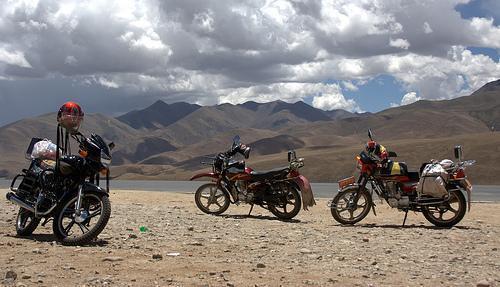How many motorcycles are in the picture?
Give a very brief answer. 3. How many tires are in the picture?
Give a very brief answer. 6. 